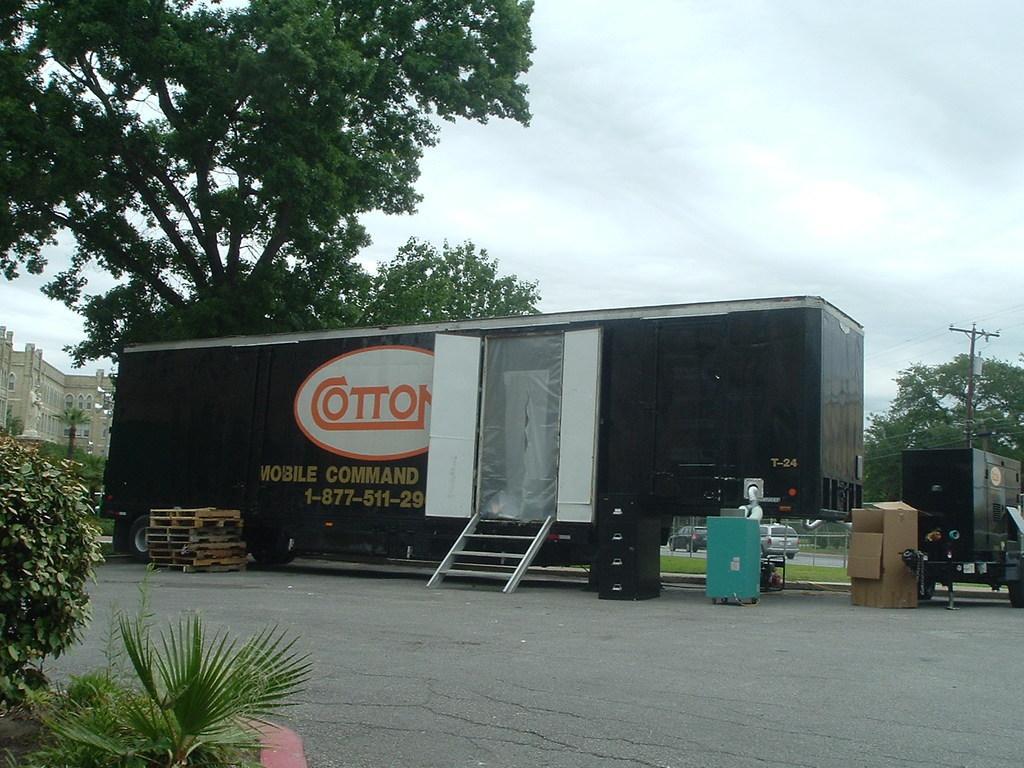Describe this image in one or two sentences. In this image we can see group of vehicles parked on the ground. In the center of the image we can see a staircase and some boxes placed on the ground. On the left side of the image we can see pallets, plants and a building with windows. In the background, we can see the poles, group of trees. At the top of the image we can see the sky. 